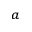Convert formula to latex. <formula><loc_0><loc_0><loc_500><loc_500>^ { a }</formula> 